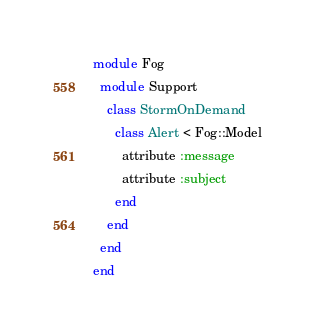<code> <loc_0><loc_0><loc_500><loc_500><_Ruby_>module Fog
  module Support
    class StormOnDemand
      class Alert < Fog::Model
        attribute :message
        attribute :subject
      end
    end
  end
end
</code> 